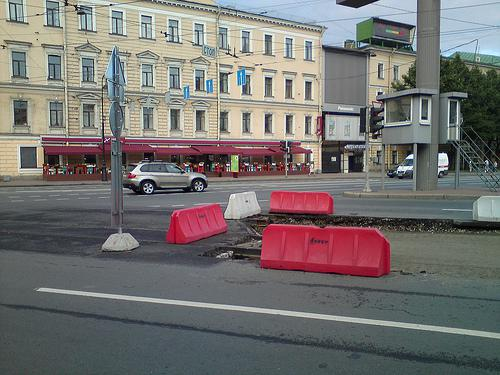Question: what are the red things in the road?
Choices:
A. Barricades.
B. Barriers.
C. Dead squirrels.
D. Tomatoes.
Answer with the letter. Answer: B Question: how many blue signs?
Choices:
A. 3.
B. 7.
C. 8.
D. 9.
Answer with the letter. Answer: A Question: how many barriers?
Choices:
A. 7.
B. 8.
C. 5.
D. 9.
Answer with the letter. Answer: C 